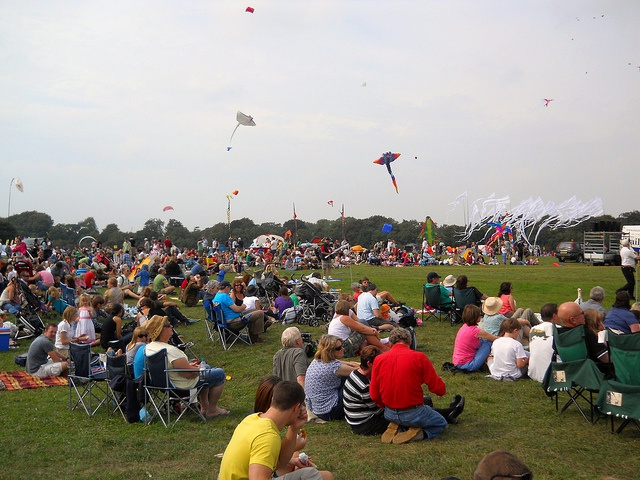Describe the objects in this image and their specific colors. I can see people in lightgray, black, olive, gray, and maroon tones, people in lightgray, maroon, black, and red tones, kite in lightgray, darkgray, gray, and black tones, people in lightgray, black, gray, and maroon tones, and chair in lightgray, black, gray, and darkgreen tones in this image. 